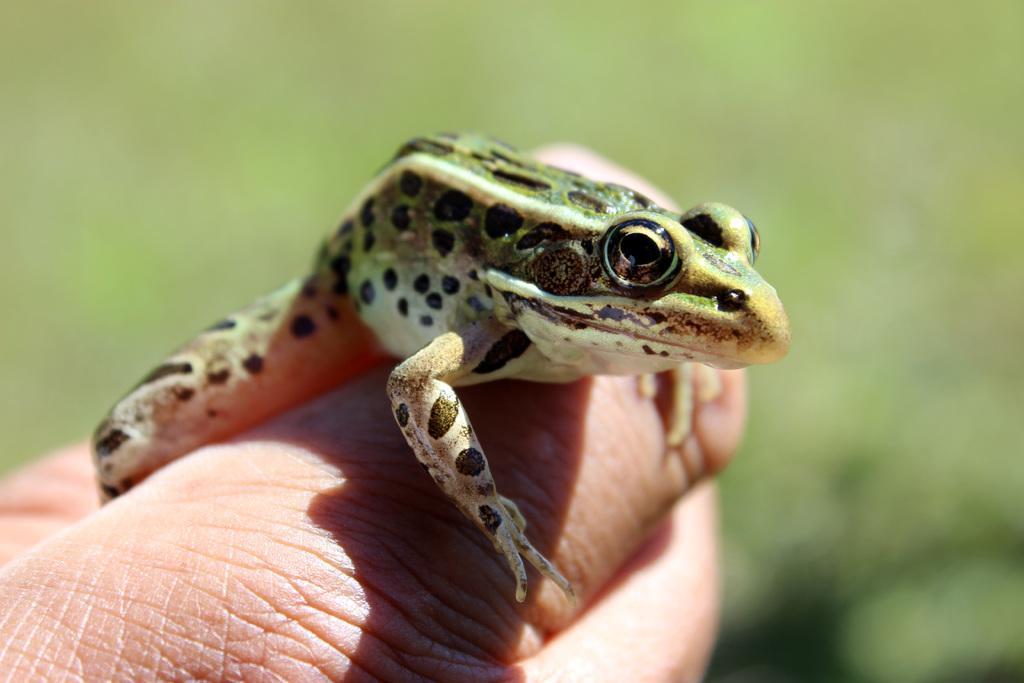Could you give a brief overview of what you see in this image? In the foreground of the picture there is a person hand, on the hand there is a frog. The background is blurred. 